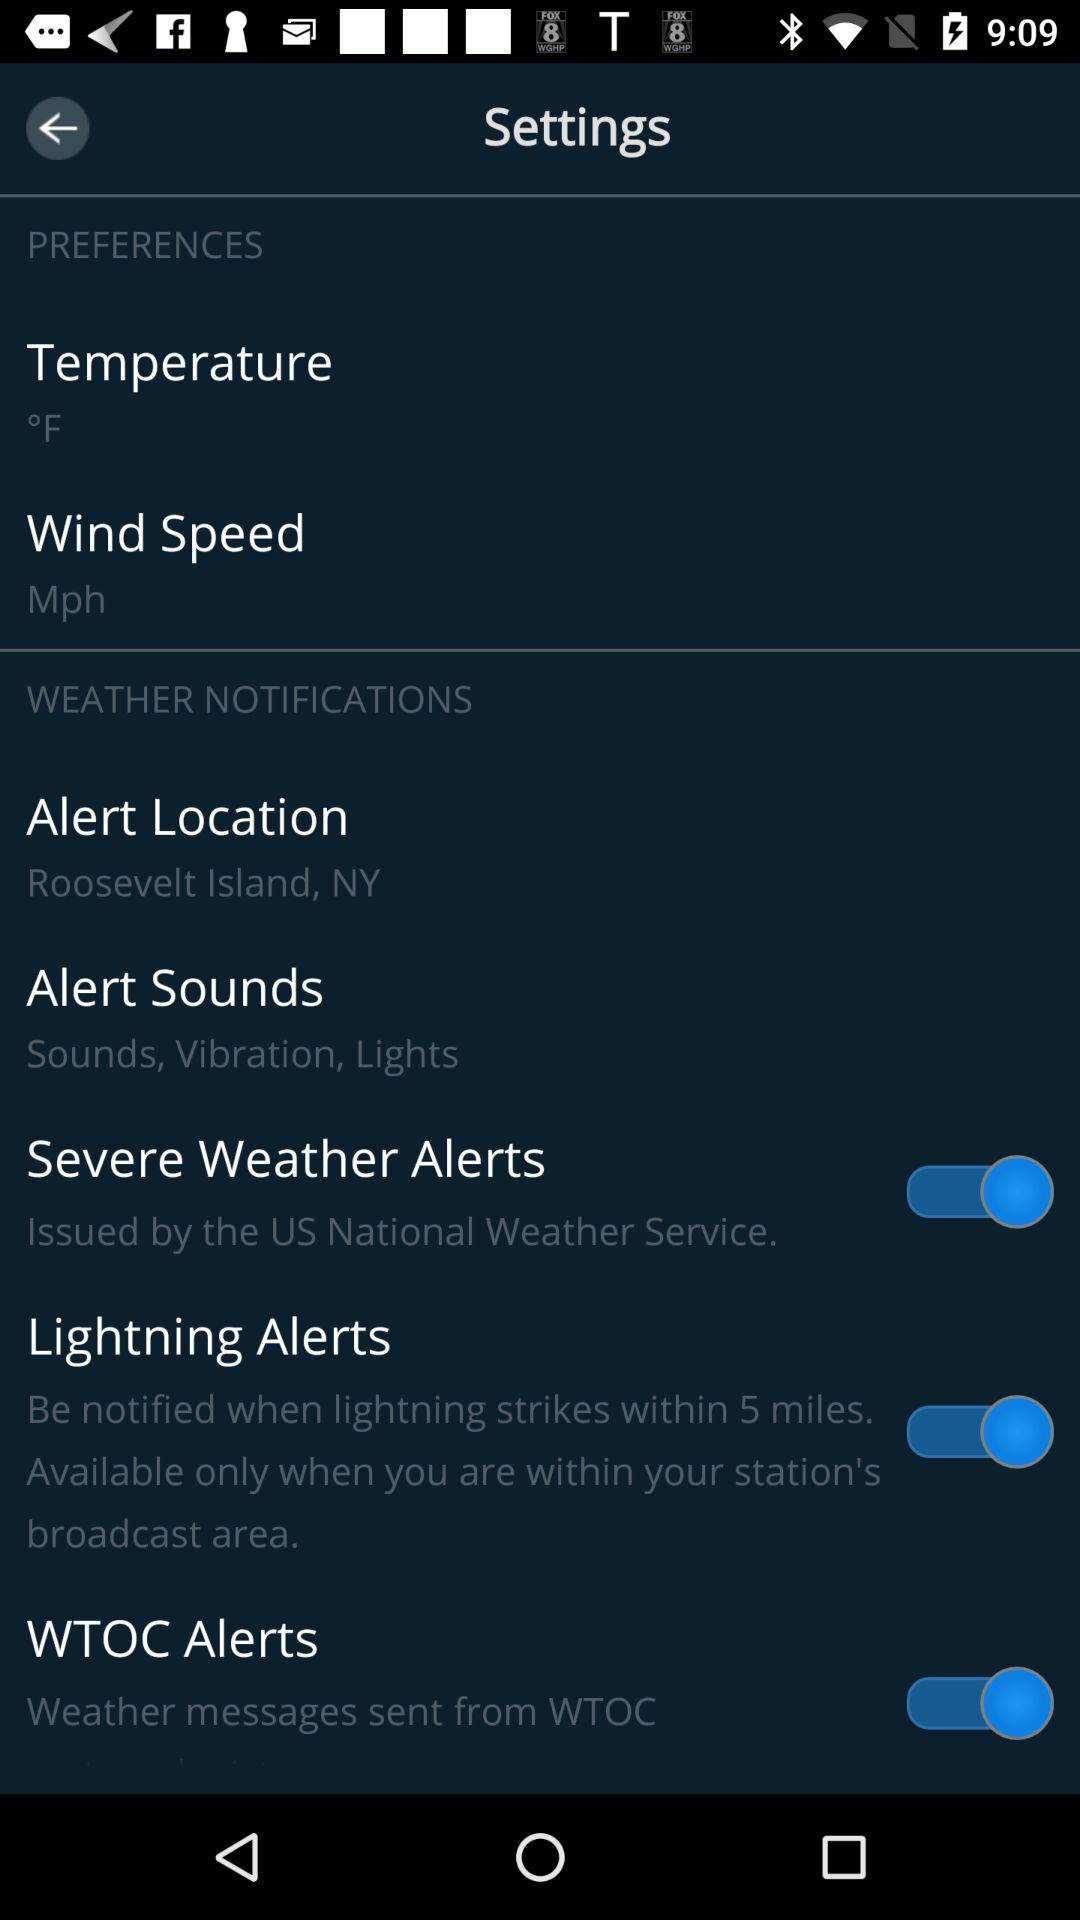What is the unit of wind speed? The unit of wind speed is "Mph". 